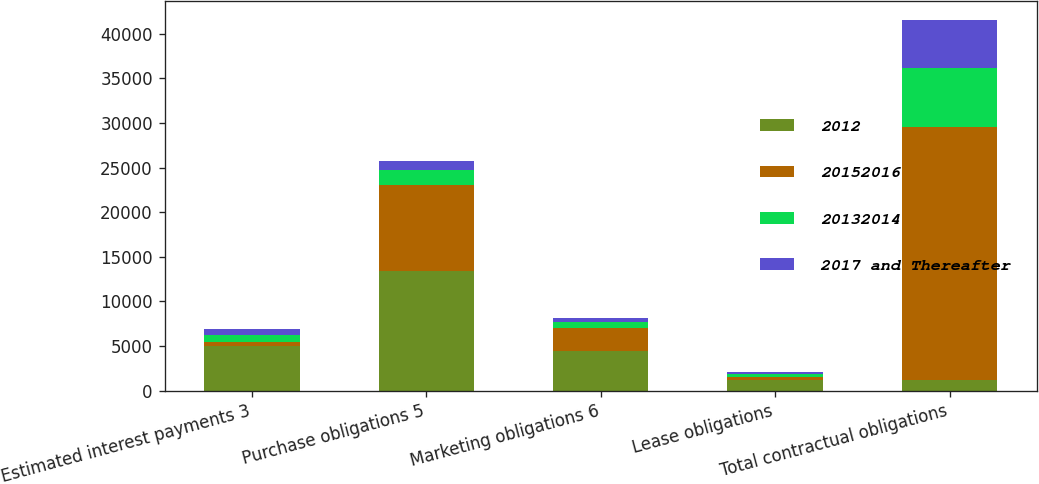<chart> <loc_0><loc_0><loc_500><loc_500><stacked_bar_chart><ecel><fcel>Estimated interest payments 3<fcel>Purchase obligations 5<fcel>Marketing obligations 6<fcel>Lease obligations<fcel>Total contractual obligations<nl><fcel>2012<fcel>5007<fcel>13357<fcel>4389<fcel>1213<fcel>1213<nl><fcel>20152016<fcel>431<fcel>9741<fcel>2600<fcel>282<fcel>28325<nl><fcel>20132014<fcel>784<fcel>1611<fcel>736<fcel>387<fcel>6625<nl><fcel>2017 and Thereafter<fcel>633<fcel>1035<fcel>421<fcel>226<fcel>5391<nl></chart> 